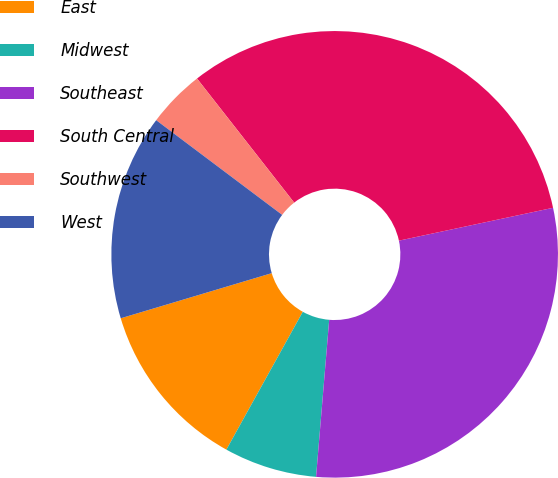<chart> <loc_0><loc_0><loc_500><loc_500><pie_chart><fcel>East<fcel>Midwest<fcel>Southeast<fcel>South Central<fcel>Southwest<fcel>West<nl><fcel>12.32%<fcel>6.73%<fcel>29.67%<fcel>32.23%<fcel>4.17%<fcel>14.88%<nl></chart> 